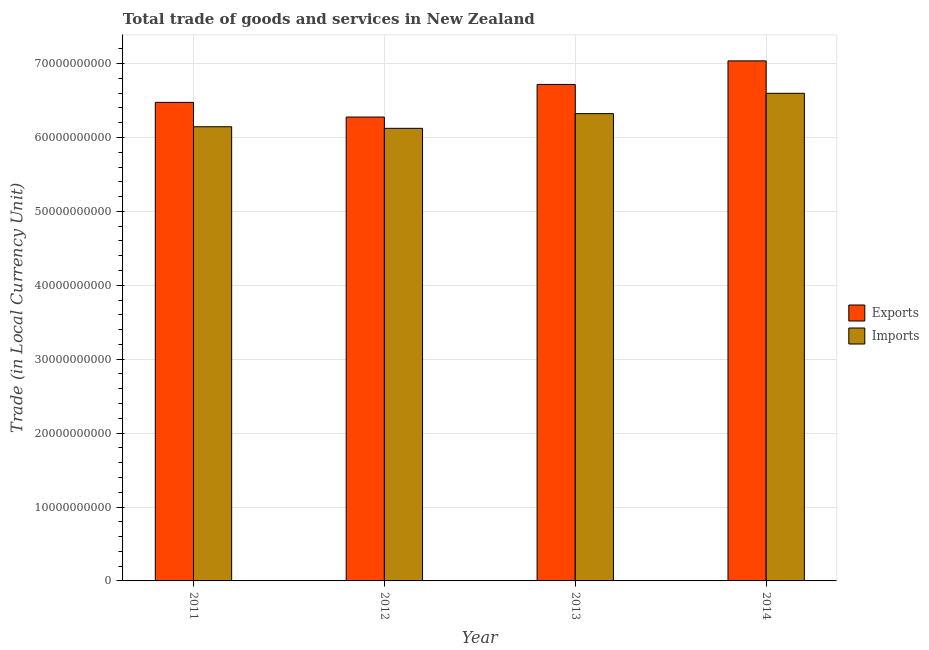How many different coloured bars are there?
Your answer should be very brief. 2. Are the number of bars on each tick of the X-axis equal?
Ensure brevity in your answer.  Yes. How many bars are there on the 2nd tick from the right?
Offer a terse response. 2. In how many cases, is the number of bars for a given year not equal to the number of legend labels?
Make the answer very short. 0. What is the imports of goods and services in 2014?
Offer a terse response. 6.60e+1. Across all years, what is the maximum imports of goods and services?
Make the answer very short. 6.60e+1. Across all years, what is the minimum imports of goods and services?
Provide a short and direct response. 6.12e+1. In which year was the export of goods and services minimum?
Your response must be concise. 2012. What is the total export of goods and services in the graph?
Offer a terse response. 2.65e+11. What is the difference between the export of goods and services in 2013 and that in 2014?
Provide a short and direct response. -3.19e+09. What is the difference between the export of goods and services in 2011 and the imports of goods and services in 2013?
Offer a very short reply. -2.43e+09. What is the average imports of goods and services per year?
Make the answer very short. 6.30e+1. In the year 2013, what is the difference between the imports of goods and services and export of goods and services?
Your answer should be very brief. 0. What is the ratio of the export of goods and services in 2012 to that in 2014?
Keep it short and to the point. 0.89. Is the difference between the export of goods and services in 2011 and 2013 greater than the difference between the imports of goods and services in 2011 and 2013?
Make the answer very short. No. What is the difference between the highest and the second highest export of goods and services?
Keep it short and to the point. 3.19e+09. What is the difference between the highest and the lowest imports of goods and services?
Make the answer very short. 4.74e+09. Is the sum of the export of goods and services in 2011 and 2012 greater than the maximum imports of goods and services across all years?
Make the answer very short. Yes. What does the 2nd bar from the left in 2012 represents?
Your response must be concise. Imports. What does the 1st bar from the right in 2011 represents?
Ensure brevity in your answer.  Imports. How many bars are there?
Ensure brevity in your answer.  8. Are all the bars in the graph horizontal?
Make the answer very short. No. How many years are there in the graph?
Make the answer very short. 4. What is the difference between two consecutive major ticks on the Y-axis?
Make the answer very short. 1.00e+1. Are the values on the major ticks of Y-axis written in scientific E-notation?
Provide a short and direct response. No. Does the graph contain any zero values?
Give a very brief answer. No. Does the graph contain grids?
Keep it short and to the point. Yes. How many legend labels are there?
Provide a short and direct response. 2. How are the legend labels stacked?
Your answer should be very brief. Vertical. What is the title of the graph?
Your answer should be compact. Total trade of goods and services in New Zealand. What is the label or title of the X-axis?
Give a very brief answer. Year. What is the label or title of the Y-axis?
Provide a succinct answer. Trade (in Local Currency Unit). What is the Trade (in Local Currency Unit) of Exports in 2011?
Offer a very short reply. 6.47e+1. What is the Trade (in Local Currency Unit) in Imports in 2011?
Give a very brief answer. 6.15e+1. What is the Trade (in Local Currency Unit) in Exports in 2012?
Offer a terse response. 6.28e+1. What is the Trade (in Local Currency Unit) of Imports in 2012?
Make the answer very short. 6.12e+1. What is the Trade (in Local Currency Unit) in Exports in 2013?
Give a very brief answer. 6.72e+1. What is the Trade (in Local Currency Unit) in Imports in 2013?
Make the answer very short. 6.32e+1. What is the Trade (in Local Currency Unit) in Exports in 2014?
Offer a terse response. 7.04e+1. What is the Trade (in Local Currency Unit) in Imports in 2014?
Provide a succinct answer. 6.60e+1. Across all years, what is the maximum Trade (in Local Currency Unit) in Exports?
Offer a terse response. 7.04e+1. Across all years, what is the maximum Trade (in Local Currency Unit) of Imports?
Make the answer very short. 6.60e+1. Across all years, what is the minimum Trade (in Local Currency Unit) in Exports?
Offer a very short reply. 6.28e+1. Across all years, what is the minimum Trade (in Local Currency Unit) of Imports?
Offer a very short reply. 6.12e+1. What is the total Trade (in Local Currency Unit) in Exports in the graph?
Provide a succinct answer. 2.65e+11. What is the total Trade (in Local Currency Unit) of Imports in the graph?
Your answer should be compact. 2.52e+11. What is the difference between the Trade (in Local Currency Unit) of Exports in 2011 and that in 2012?
Provide a succinct answer. 1.99e+09. What is the difference between the Trade (in Local Currency Unit) of Imports in 2011 and that in 2012?
Offer a very short reply. 2.15e+08. What is the difference between the Trade (in Local Currency Unit) in Exports in 2011 and that in 2013?
Your answer should be compact. -2.43e+09. What is the difference between the Trade (in Local Currency Unit) in Imports in 2011 and that in 2013?
Keep it short and to the point. -1.78e+09. What is the difference between the Trade (in Local Currency Unit) in Exports in 2011 and that in 2014?
Keep it short and to the point. -5.61e+09. What is the difference between the Trade (in Local Currency Unit) of Imports in 2011 and that in 2014?
Offer a very short reply. -4.52e+09. What is the difference between the Trade (in Local Currency Unit) of Exports in 2012 and that in 2013?
Your response must be concise. -4.41e+09. What is the difference between the Trade (in Local Currency Unit) in Imports in 2012 and that in 2013?
Make the answer very short. -1.99e+09. What is the difference between the Trade (in Local Currency Unit) in Exports in 2012 and that in 2014?
Provide a short and direct response. -7.60e+09. What is the difference between the Trade (in Local Currency Unit) in Imports in 2012 and that in 2014?
Your response must be concise. -4.74e+09. What is the difference between the Trade (in Local Currency Unit) of Exports in 2013 and that in 2014?
Offer a very short reply. -3.19e+09. What is the difference between the Trade (in Local Currency Unit) of Imports in 2013 and that in 2014?
Your response must be concise. -2.75e+09. What is the difference between the Trade (in Local Currency Unit) of Exports in 2011 and the Trade (in Local Currency Unit) of Imports in 2012?
Your answer should be compact. 3.51e+09. What is the difference between the Trade (in Local Currency Unit) of Exports in 2011 and the Trade (in Local Currency Unit) of Imports in 2013?
Provide a succinct answer. 1.52e+09. What is the difference between the Trade (in Local Currency Unit) of Exports in 2011 and the Trade (in Local Currency Unit) of Imports in 2014?
Make the answer very short. -1.23e+09. What is the difference between the Trade (in Local Currency Unit) of Exports in 2012 and the Trade (in Local Currency Unit) of Imports in 2013?
Your response must be concise. -4.64e+08. What is the difference between the Trade (in Local Currency Unit) of Exports in 2012 and the Trade (in Local Currency Unit) of Imports in 2014?
Offer a very short reply. -3.21e+09. What is the difference between the Trade (in Local Currency Unit) in Exports in 2013 and the Trade (in Local Currency Unit) in Imports in 2014?
Offer a very short reply. 1.20e+09. What is the average Trade (in Local Currency Unit) in Exports per year?
Ensure brevity in your answer.  6.63e+1. What is the average Trade (in Local Currency Unit) of Imports per year?
Provide a short and direct response. 6.30e+1. In the year 2011, what is the difference between the Trade (in Local Currency Unit) in Exports and Trade (in Local Currency Unit) in Imports?
Your answer should be very brief. 3.30e+09. In the year 2012, what is the difference between the Trade (in Local Currency Unit) in Exports and Trade (in Local Currency Unit) in Imports?
Provide a short and direct response. 1.53e+09. In the year 2013, what is the difference between the Trade (in Local Currency Unit) of Exports and Trade (in Local Currency Unit) of Imports?
Provide a short and direct response. 3.95e+09. In the year 2014, what is the difference between the Trade (in Local Currency Unit) of Exports and Trade (in Local Currency Unit) of Imports?
Offer a terse response. 4.39e+09. What is the ratio of the Trade (in Local Currency Unit) in Exports in 2011 to that in 2012?
Your response must be concise. 1.03. What is the ratio of the Trade (in Local Currency Unit) in Exports in 2011 to that in 2013?
Make the answer very short. 0.96. What is the ratio of the Trade (in Local Currency Unit) of Imports in 2011 to that in 2013?
Make the answer very short. 0.97. What is the ratio of the Trade (in Local Currency Unit) of Exports in 2011 to that in 2014?
Offer a very short reply. 0.92. What is the ratio of the Trade (in Local Currency Unit) in Imports in 2011 to that in 2014?
Your answer should be very brief. 0.93. What is the ratio of the Trade (in Local Currency Unit) of Exports in 2012 to that in 2013?
Offer a very short reply. 0.93. What is the ratio of the Trade (in Local Currency Unit) of Imports in 2012 to that in 2013?
Offer a very short reply. 0.97. What is the ratio of the Trade (in Local Currency Unit) in Exports in 2012 to that in 2014?
Your response must be concise. 0.89. What is the ratio of the Trade (in Local Currency Unit) of Imports in 2012 to that in 2014?
Your answer should be very brief. 0.93. What is the ratio of the Trade (in Local Currency Unit) in Exports in 2013 to that in 2014?
Ensure brevity in your answer.  0.95. What is the ratio of the Trade (in Local Currency Unit) of Imports in 2013 to that in 2014?
Make the answer very short. 0.96. What is the difference between the highest and the second highest Trade (in Local Currency Unit) in Exports?
Your answer should be compact. 3.19e+09. What is the difference between the highest and the second highest Trade (in Local Currency Unit) in Imports?
Offer a terse response. 2.75e+09. What is the difference between the highest and the lowest Trade (in Local Currency Unit) of Exports?
Give a very brief answer. 7.60e+09. What is the difference between the highest and the lowest Trade (in Local Currency Unit) in Imports?
Offer a very short reply. 4.74e+09. 